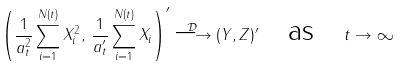<formula> <loc_0><loc_0><loc_500><loc_500>\left ( \frac { 1 } { a _ { t } ^ { 2 } } \sum _ { i = 1 } ^ { N ( t ) } X _ { i } ^ { 2 } , \, \frac { 1 } { a ^ { \prime } _ { t } } \sum _ { i = 1 } ^ { N ( t ) } X _ { i } \right ) ^ { \prime } \stackrel { \mathcal { D } } { \longrightarrow } ( Y , Z ) ^ { \prime } \quad \text {as} \quad t \rightarrow \infty</formula> 